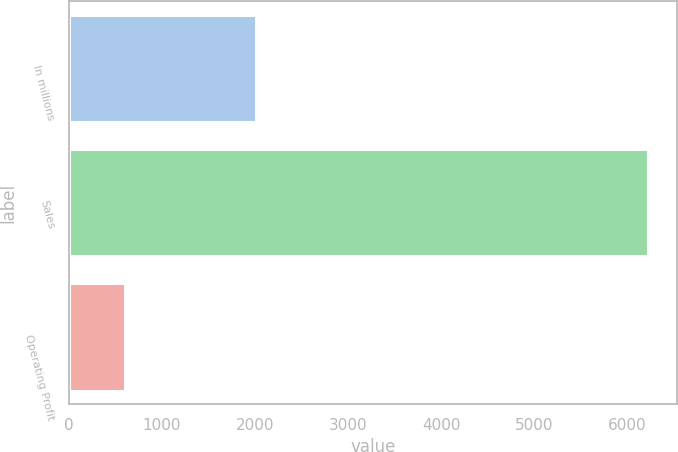Convert chart to OTSL. <chart><loc_0><loc_0><loc_500><loc_500><bar_chart><fcel>In millions<fcel>Sales<fcel>Operating Profit<nl><fcel>2012<fcel>6230<fcel>599<nl></chart> 